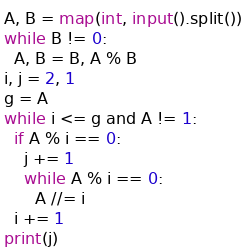Convert code to text. <code><loc_0><loc_0><loc_500><loc_500><_Python_>A, B = map(int, input().split())
while B != 0:
  A, B = B, A % B
i, j = 2, 1
g = A
while i <= g and A != 1:
  if A % i == 0:
    j += 1
    while A % i == 0:
      A //= i
  i += 1
print(j)</code> 